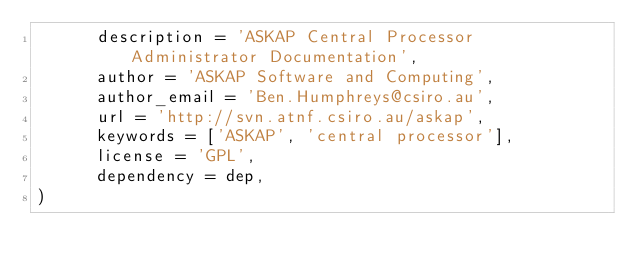Convert code to text. <code><loc_0><loc_0><loc_500><loc_500><_Python_>      description = 'ASKAP Central Processor Administrator Documentation',
      author = 'ASKAP Software and Computing',
      author_email = 'Ben.Humphreys@csiro.au',
      url = 'http://svn.atnf.csiro.au/askap',
      keywords = ['ASKAP', 'central processor'],
      license = 'GPL',
      dependency = dep,
)
</code> 